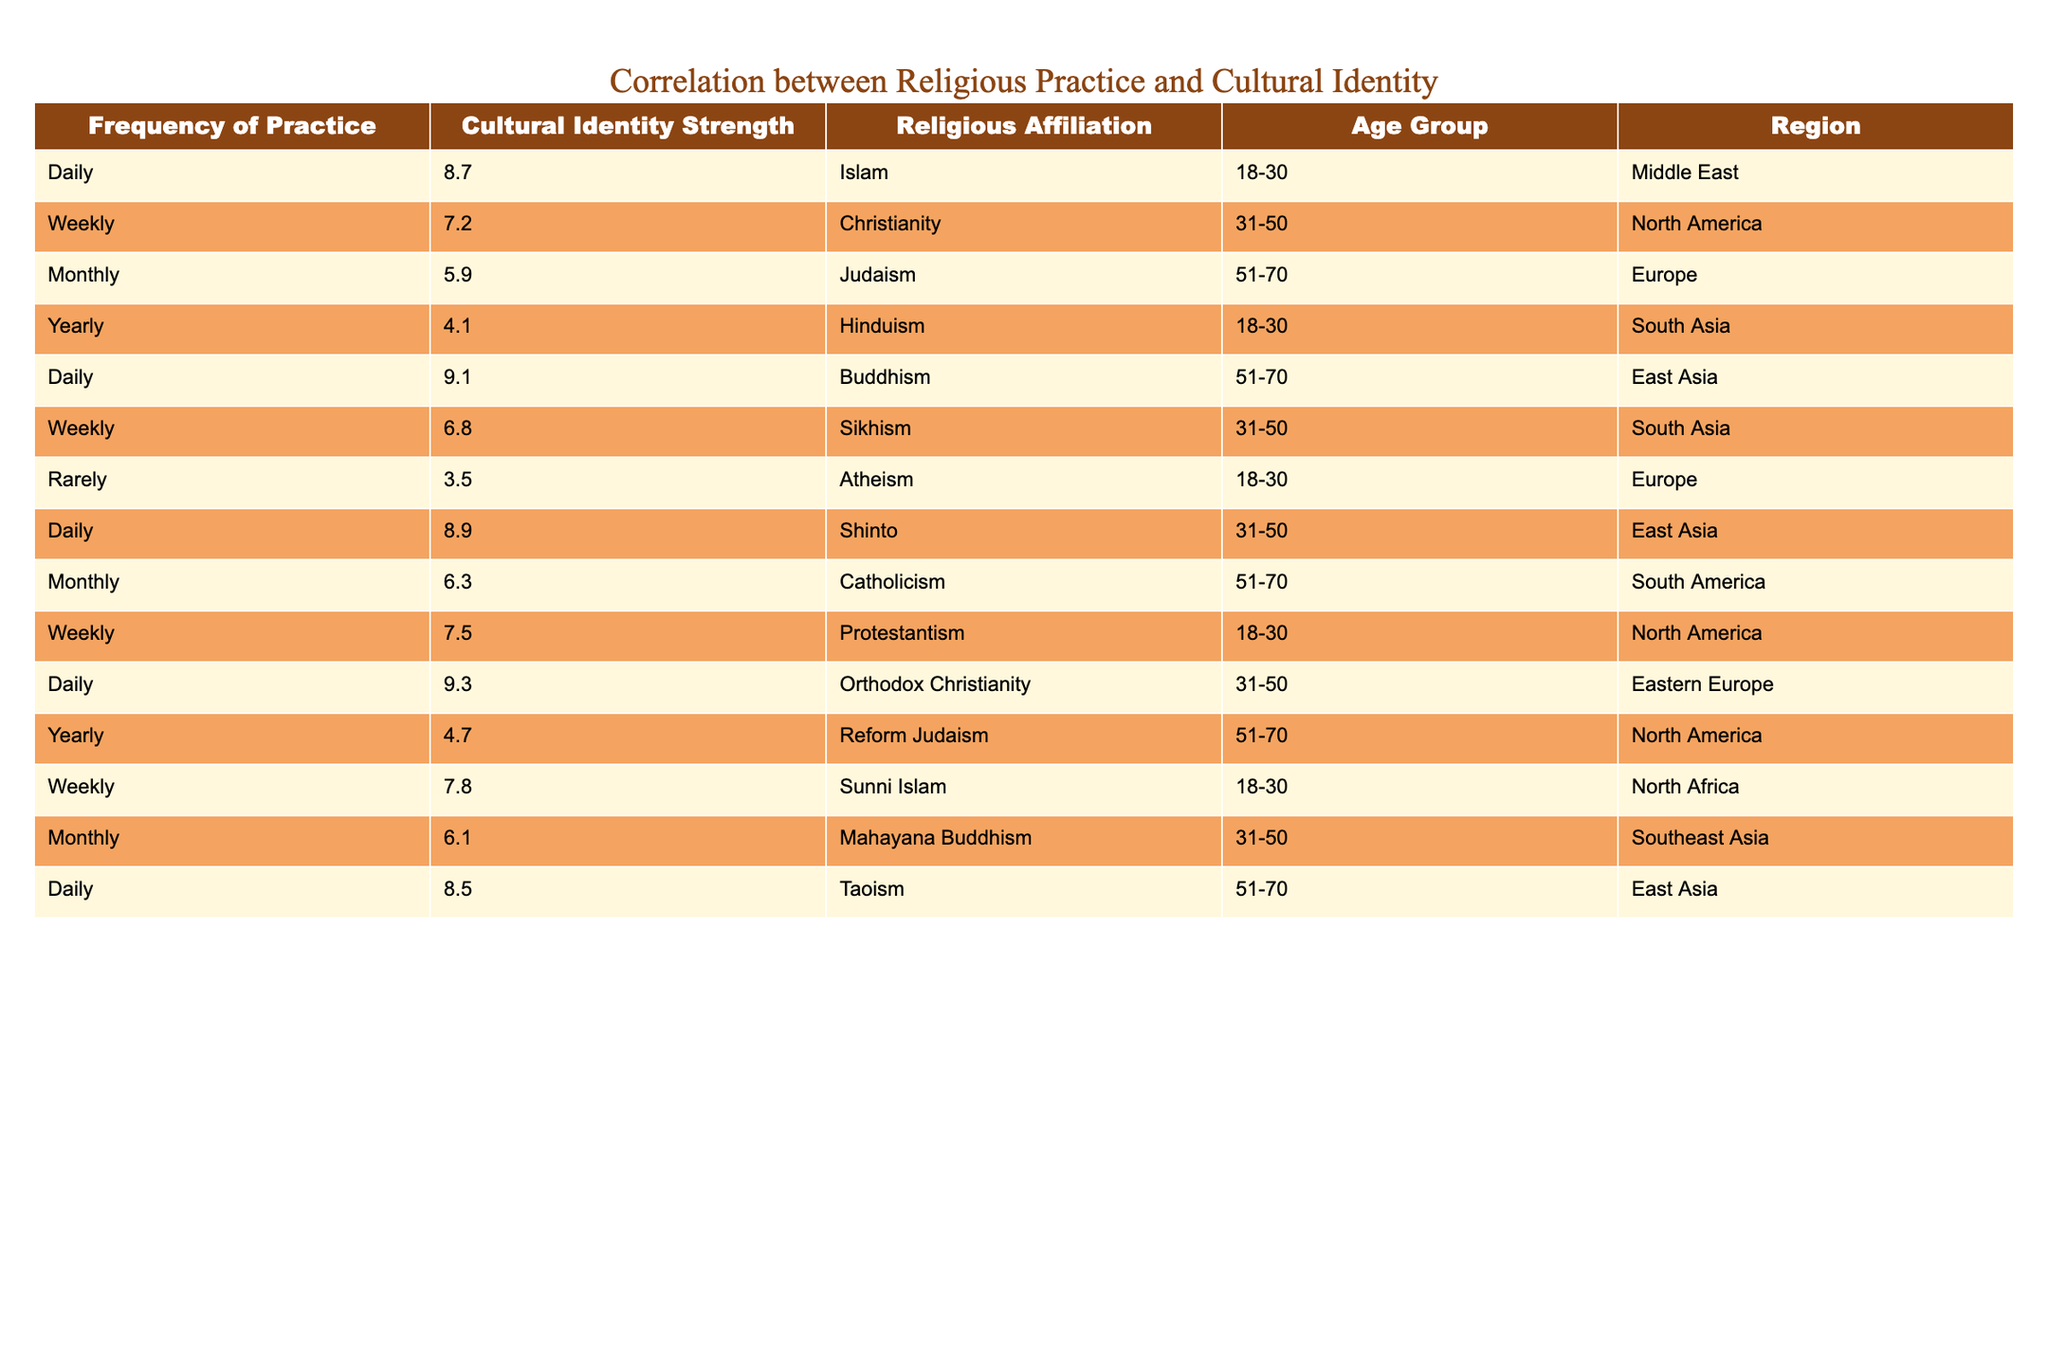What is the cultural identity strength for those who practice Buddhism daily? In the table, I can find the row with Buddhism and check the corresponding value in the Cultural Identity Strength column. It states that the strength is 9.1.
Answer: 9.1 Which age group has the highest cultural identity strength for daily religious practice? Looking at the rows for daily practice, the highest value in the Cultural Identity Strength column belongs to the Middle East age group (18-30) with a strength of 8.7, compared to others.
Answer: 18-30 How do the cultural identity strengths for weekly practices compare between Christianity and Sunni Islam? For Christianity, the cultural identity strength is 7.2, and for Sunni Islam, it is 7.8. Making a difference: 7.8 - 7.2 = 0.6, indicating that Sunni Islam has a higher strength by 0.6.
Answer: 0.6 Is there a correlation between the frequency of practice and cultural identity strength in this data? I would analyze values across different frequencies. For example, daily practices tend to have higher identity strengths, while rare practices have lower strengths. This suggests a positive correlation.
Answer: Yes What is the average cultural identity strength for monthly practices across all religions? Calculating the average, I sum the values for monthly practices (5.9 + 6.3 + 6.1) = 18.3, and then divide by the number of entries (3) for monthly practices, which gives 18.3 / 3 = 6.1.
Answer: 6.1 Which religious affiliation has the lowest cultural identity strength, and what is its value? Looking through the rows, Atheism shows a cultural identity strength of 3.5, which is lower than all other values listed.
Answer: Atheism, 3.5 What is the difference in cultural identity strength between the highest and lowest recorded values in the data? Identifying the highest (9.3 for Orthodox Christianity) and the lowest (3.5 for Atheism), I subtract: 9.3 - 3.5 = 5.8, showing the range of values.
Answer: 5.8 Which region has the highest reported cultural identity strength for any religious affiliation? The highest strength is recorded for Buddhism in East Asia at 9.1, making East Asia the region with the highest cultural identity strength.
Answer: East Asia How many religious affiliations practice monthly, and what is their combined cultural identity strength? There are three monthly practices noted (Judaism, Catholicism, Mahayana Buddhism) with values: 5.9, 6.3, and 6.1, summing them gives 5.9 + 6.3 + 6.1 = 18.3.
Answer: 18.3 Is there a religious affiliation that reports a cultural identity strength over 9? By reviewing the table, both Buddhism and Orthodox Christianity have strengths above 9 (9.1 and 9.3, respectively), confirming that such affiliations exist.
Answer: Yes 